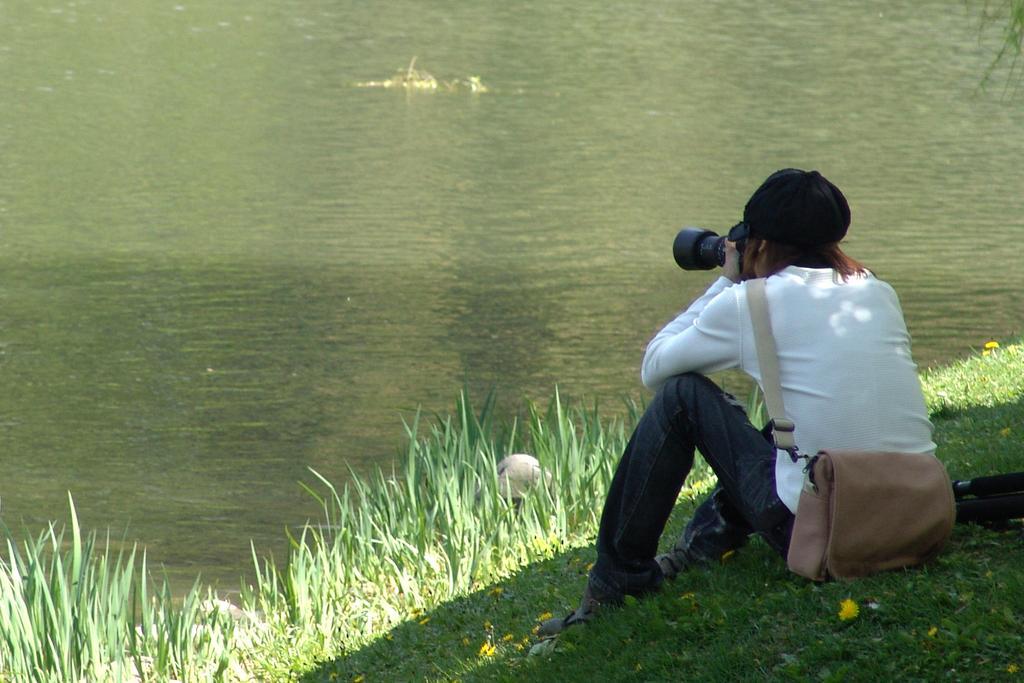Can you describe this image briefly? In this image I can see a person is sitting and holding a camera. The person is carrying a bag. The person is wearing a cap. Here I can see the grass. In the background I can see water. 